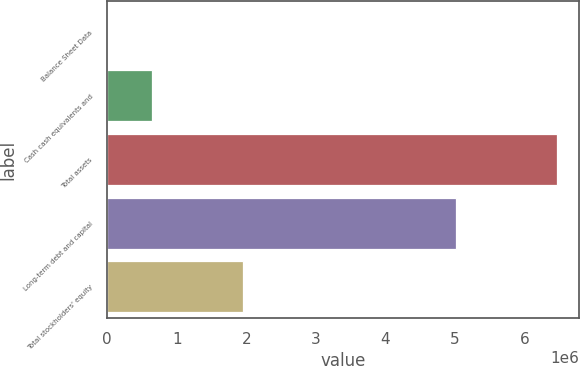Convert chart to OTSL. <chart><loc_0><loc_0><loc_500><loc_500><bar_chart><fcel>Balance Sheet Data<fcel>Cash cash equivalents and<fcel>Total assets<fcel>Long-term debt and capital<fcel>Total stockholders' equity<nl><fcel>2008<fcel>647812<fcel>6.46005e+06<fcel>5.00776e+06<fcel>1.94911e+06<nl></chart> 